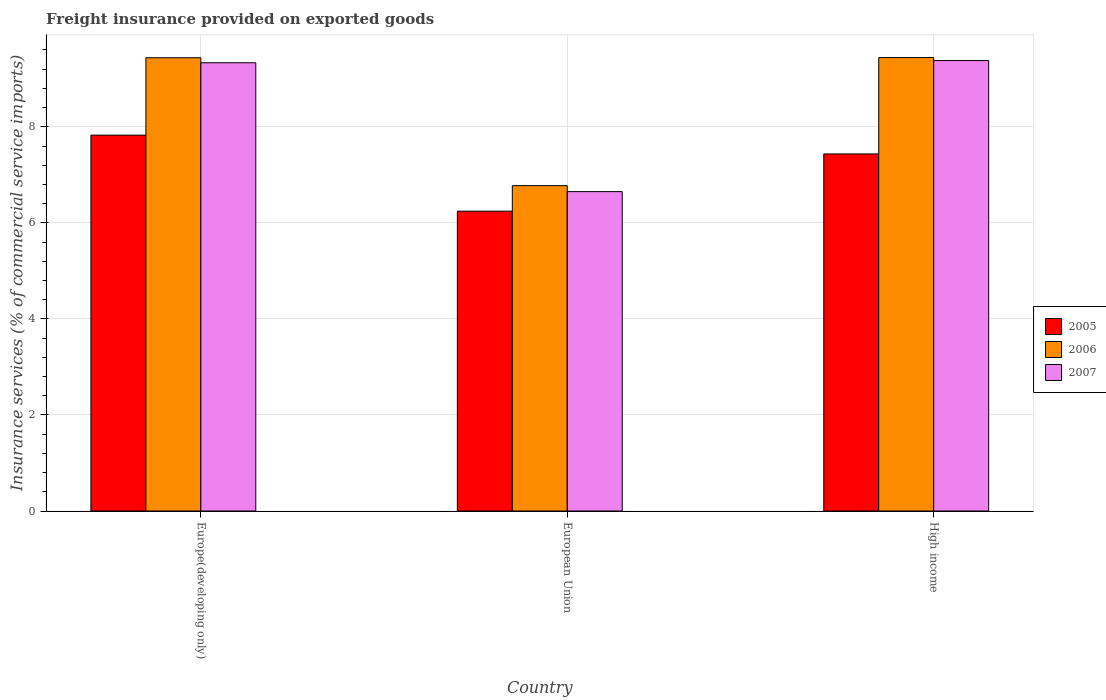How many different coloured bars are there?
Offer a terse response. 3. How many groups of bars are there?
Offer a very short reply. 3. Are the number of bars on each tick of the X-axis equal?
Offer a terse response. Yes. How many bars are there on the 3rd tick from the left?
Provide a short and direct response. 3. What is the label of the 2nd group of bars from the left?
Provide a succinct answer. European Union. What is the freight insurance provided on exported goods in 2006 in High income?
Keep it short and to the point. 9.44. Across all countries, what is the maximum freight insurance provided on exported goods in 2006?
Ensure brevity in your answer.  9.44. Across all countries, what is the minimum freight insurance provided on exported goods in 2006?
Keep it short and to the point. 6.77. In which country was the freight insurance provided on exported goods in 2006 maximum?
Provide a succinct answer. High income. What is the total freight insurance provided on exported goods in 2007 in the graph?
Provide a succinct answer. 25.36. What is the difference between the freight insurance provided on exported goods in 2005 in European Union and that in High income?
Offer a very short reply. -1.19. What is the difference between the freight insurance provided on exported goods in 2006 in Europe(developing only) and the freight insurance provided on exported goods in 2007 in High income?
Your response must be concise. 0.06. What is the average freight insurance provided on exported goods in 2006 per country?
Keep it short and to the point. 8.55. What is the difference between the freight insurance provided on exported goods of/in 2006 and freight insurance provided on exported goods of/in 2007 in High income?
Give a very brief answer. 0.06. What is the ratio of the freight insurance provided on exported goods in 2005 in European Union to that in High income?
Offer a very short reply. 0.84. Is the difference between the freight insurance provided on exported goods in 2006 in European Union and High income greater than the difference between the freight insurance provided on exported goods in 2007 in European Union and High income?
Your answer should be very brief. Yes. What is the difference between the highest and the second highest freight insurance provided on exported goods in 2005?
Make the answer very short. 1.19. What is the difference between the highest and the lowest freight insurance provided on exported goods in 2007?
Provide a succinct answer. 2.73. In how many countries, is the freight insurance provided on exported goods in 2006 greater than the average freight insurance provided on exported goods in 2006 taken over all countries?
Ensure brevity in your answer.  2. Is the sum of the freight insurance provided on exported goods in 2005 in Europe(developing only) and European Union greater than the maximum freight insurance provided on exported goods in 2006 across all countries?
Provide a succinct answer. Yes. What does the 2nd bar from the left in Europe(developing only) represents?
Make the answer very short. 2006. Is it the case that in every country, the sum of the freight insurance provided on exported goods in 2005 and freight insurance provided on exported goods in 2007 is greater than the freight insurance provided on exported goods in 2006?
Offer a terse response. Yes. How many bars are there?
Keep it short and to the point. 9. How many countries are there in the graph?
Offer a terse response. 3. What is the difference between two consecutive major ticks on the Y-axis?
Your answer should be very brief. 2. Are the values on the major ticks of Y-axis written in scientific E-notation?
Offer a terse response. No. Does the graph contain any zero values?
Ensure brevity in your answer.  No. Where does the legend appear in the graph?
Offer a terse response. Center right. What is the title of the graph?
Keep it short and to the point. Freight insurance provided on exported goods. Does "1970" appear as one of the legend labels in the graph?
Offer a terse response. No. What is the label or title of the X-axis?
Your response must be concise. Country. What is the label or title of the Y-axis?
Offer a very short reply. Insurance services (% of commercial service imports). What is the Insurance services (% of commercial service imports) of 2005 in Europe(developing only)?
Provide a succinct answer. 7.83. What is the Insurance services (% of commercial service imports) of 2006 in Europe(developing only)?
Your response must be concise. 9.44. What is the Insurance services (% of commercial service imports) in 2007 in Europe(developing only)?
Offer a very short reply. 9.33. What is the Insurance services (% of commercial service imports) of 2005 in European Union?
Keep it short and to the point. 6.24. What is the Insurance services (% of commercial service imports) in 2006 in European Union?
Ensure brevity in your answer.  6.77. What is the Insurance services (% of commercial service imports) of 2007 in European Union?
Offer a terse response. 6.65. What is the Insurance services (% of commercial service imports) of 2005 in High income?
Keep it short and to the point. 7.43. What is the Insurance services (% of commercial service imports) of 2006 in High income?
Keep it short and to the point. 9.44. What is the Insurance services (% of commercial service imports) of 2007 in High income?
Make the answer very short. 9.38. Across all countries, what is the maximum Insurance services (% of commercial service imports) in 2005?
Your response must be concise. 7.83. Across all countries, what is the maximum Insurance services (% of commercial service imports) in 2006?
Offer a very short reply. 9.44. Across all countries, what is the maximum Insurance services (% of commercial service imports) of 2007?
Provide a succinct answer. 9.38. Across all countries, what is the minimum Insurance services (% of commercial service imports) in 2005?
Your answer should be very brief. 6.24. Across all countries, what is the minimum Insurance services (% of commercial service imports) of 2006?
Make the answer very short. 6.77. Across all countries, what is the minimum Insurance services (% of commercial service imports) of 2007?
Make the answer very short. 6.65. What is the total Insurance services (% of commercial service imports) in 2005 in the graph?
Your answer should be very brief. 21.5. What is the total Insurance services (% of commercial service imports) of 2006 in the graph?
Provide a short and direct response. 25.65. What is the total Insurance services (% of commercial service imports) of 2007 in the graph?
Your answer should be compact. 25.36. What is the difference between the Insurance services (% of commercial service imports) in 2005 in Europe(developing only) and that in European Union?
Your response must be concise. 1.58. What is the difference between the Insurance services (% of commercial service imports) of 2006 in Europe(developing only) and that in European Union?
Give a very brief answer. 2.66. What is the difference between the Insurance services (% of commercial service imports) of 2007 in Europe(developing only) and that in European Union?
Make the answer very short. 2.68. What is the difference between the Insurance services (% of commercial service imports) in 2005 in Europe(developing only) and that in High income?
Offer a very short reply. 0.39. What is the difference between the Insurance services (% of commercial service imports) in 2006 in Europe(developing only) and that in High income?
Provide a short and direct response. -0. What is the difference between the Insurance services (% of commercial service imports) of 2007 in Europe(developing only) and that in High income?
Provide a short and direct response. -0.05. What is the difference between the Insurance services (% of commercial service imports) of 2005 in European Union and that in High income?
Ensure brevity in your answer.  -1.19. What is the difference between the Insurance services (% of commercial service imports) in 2006 in European Union and that in High income?
Your response must be concise. -2.67. What is the difference between the Insurance services (% of commercial service imports) of 2007 in European Union and that in High income?
Offer a terse response. -2.73. What is the difference between the Insurance services (% of commercial service imports) of 2005 in Europe(developing only) and the Insurance services (% of commercial service imports) of 2006 in European Union?
Your answer should be compact. 1.05. What is the difference between the Insurance services (% of commercial service imports) of 2005 in Europe(developing only) and the Insurance services (% of commercial service imports) of 2007 in European Union?
Your response must be concise. 1.18. What is the difference between the Insurance services (% of commercial service imports) of 2006 in Europe(developing only) and the Insurance services (% of commercial service imports) of 2007 in European Union?
Your response must be concise. 2.79. What is the difference between the Insurance services (% of commercial service imports) in 2005 in Europe(developing only) and the Insurance services (% of commercial service imports) in 2006 in High income?
Your response must be concise. -1.62. What is the difference between the Insurance services (% of commercial service imports) of 2005 in Europe(developing only) and the Insurance services (% of commercial service imports) of 2007 in High income?
Offer a terse response. -1.55. What is the difference between the Insurance services (% of commercial service imports) of 2006 in Europe(developing only) and the Insurance services (% of commercial service imports) of 2007 in High income?
Your answer should be very brief. 0.06. What is the difference between the Insurance services (% of commercial service imports) in 2005 in European Union and the Insurance services (% of commercial service imports) in 2006 in High income?
Provide a short and direct response. -3.2. What is the difference between the Insurance services (% of commercial service imports) in 2005 in European Union and the Insurance services (% of commercial service imports) in 2007 in High income?
Your answer should be compact. -3.14. What is the difference between the Insurance services (% of commercial service imports) of 2006 in European Union and the Insurance services (% of commercial service imports) of 2007 in High income?
Offer a very short reply. -2.6. What is the average Insurance services (% of commercial service imports) of 2005 per country?
Offer a terse response. 7.17. What is the average Insurance services (% of commercial service imports) in 2006 per country?
Offer a very short reply. 8.55. What is the average Insurance services (% of commercial service imports) in 2007 per country?
Your answer should be compact. 8.45. What is the difference between the Insurance services (% of commercial service imports) in 2005 and Insurance services (% of commercial service imports) in 2006 in Europe(developing only)?
Offer a terse response. -1.61. What is the difference between the Insurance services (% of commercial service imports) in 2005 and Insurance services (% of commercial service imports) in 2007 in Europe(developing only)?
Your answer should be very brief. -1.51. What is the difference between the Insurance services (% of commercial service imports) of 2006 and Insurance services (% of commercial service imports) of 2007 in Europe(developing only)?
Your answer should be very brief. 0.1. What is the difference between the Insurance services (% of commercial service imports) of 2005 and Insurance services (% of commercial service imports) of 2006 in European Union?
Offer a very short reply. -0.53. What is the difference between the Insurance services (% of commercial service imports) of 2005 and Insurance services (% of commercial service imports) of 2007 in European Union?
Your response must be concise. -0.41. What is the difference between the Insurance services (% of commercial service imports) in 2006 and Insurance services (% of commercial service imports) in 2007 in European Union?
Offer a terse response. 0.12. What is the difference between the Insurance services (% of commercial service imports) of 2005 and Insurance services (% of commercial service imports) of 2006 in High income?
Offer a very short reply. -2.01. What is the difference between the Insurance services (% of commercial service imports) of 2005 and Insurance services (% of commercial service imports) of 2007 in High income?
Make the answer very short. -1.94. What is the difference between the Insurance services (% of commercial service imports) in 2006 and Insurance services (% of commercial service imports) in 2007 in High income?
Keep it short and to the point. 0.06. What is the ratio of the Insurance services (% of commercial service imports) in 2005 in Europe(developing only) to that in European Union?
Provide a short and direct response. 1.25. What is the ratio of the Insurance services (% of commercial service imports) of 2006 in Europe(developing only) to that in European Union?
Keep it short and to the point. 1.39. What is the ratio of the Insurance services (% of commercial service imports) in 2007 in Europe(developing only) to that in European Union?
Your response must be concise. 1.4. What is the ratio of the Insurance services (% of commercial service imports) in 2005 in Europe(developing only) to that in High income?
Provide a short and direct response. 1.05. What is the ratio of the Insurance services (% of commercial service imports) of 2006 in Europe(developing only) to that in High income?
Make the answer very short. 1. What is the ratio of the Insurance services (% of commercial service imports) in 2007 in Europe(developing only) to that in High income?
Offer a terse response. 1. What is the ratio of the Insurance services (% of commercial service imports) of 2005 in European Union to that in High income?
Give a very brief answer. 0.84. What is the ratio of the Insurance services (% of commercial service imports) in 2006 in European Union to that in High income?
Your response must be concise. 0.72. What is the ratio of the Insurance services (% of commercial service imports) in 2007 in European Union to that in High income?
Your response must be concise. 0.71. What is the difference between the highest and the second highest Insurance services (% of commercial service imports) in 2005?
Your answer should be very brief. 0.39. What is the difference between the highest and the second highest Insurance services (% of commercial service imports) in 2006?
Your answer should be very brief. 0. What is the difference between the highest and the second highest Insurance services (% of commercial service imports) in 2007?
Ensure brevity in your answer.  0.05. What is the difference between the highest and the lowest Insurance services (% of commercial service imports) of 2005?
Offer a very short reply. 1.58. What is the difference between the highest and the lowest Insurance services (% of commercial service imports) in 2006?
Provide a succinct answer. 2.67. What is the difference between the highest and the lowest Insurance services (% of commercial service imports) in 2007?
Your answer should be very brief. 2.73. 